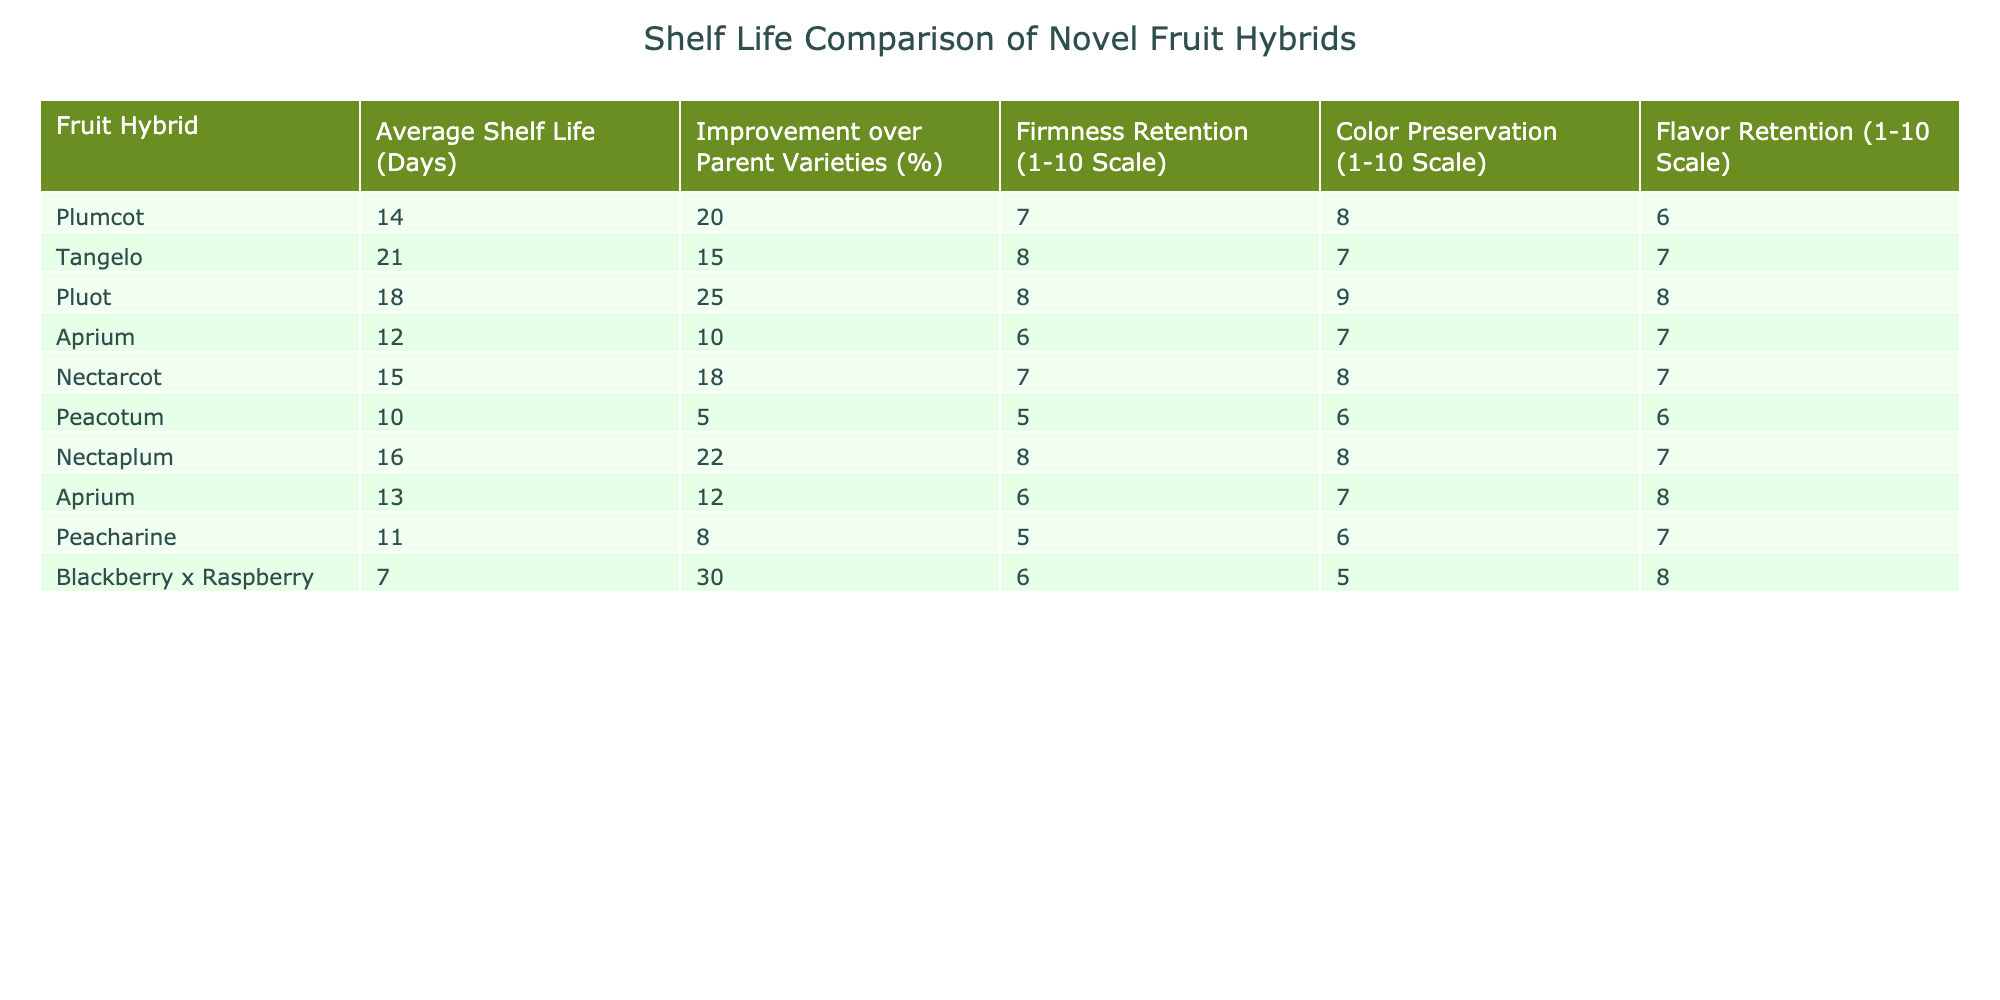What is the fruit hybrid with the longest average shelf life? By looking at the "Average Shelf Life (Days)" column, Tangelo has the highest value at 21 days compared to the other hybrids.
Answer: Tangelo Which fruit hybrid shows the greatest improvement over parent varieties? The "Improvement over Parent Varieties (%)" column shows that Blackberry x Raspberry has the highest percentage at 30%.
Answer: Blackberry x Raspberry What is the average firmness retention score for all fruit hybrids? Sum the firmness retention scores: 7 + 8 + 8 + 6 + 7 + 5 + 8 + 6 + 5 + 6 = 66. There are 10 hybrids, so the average is 66/10 = 6.6.
Answer: 6.6 How many fruit hybrids have an average shelf life greater than 15 days? The hybrids with shelf life greater than 15 days are Tangelo, Pluot, Nectaplum, and Plumcot. That makes a total of 4 hybrids.
Answer: 4 Is the flavor retention of the Plumcot higher than that of Peacotum? Comparing the "Flavor Retention (1-10 Scale)" values, Plumcot has a score of 6 while Peacotum has a score of 6. Therefore, Plumcot's flavor retention is not higher.
Answer: No Which fruit hybrids have both color and flavor retention scores of 8 or higher? Checking the "Color Preservation" and "Flavor Retention" columns, Pluot and Nectaplum both score 8 or higher in both categories.
Answer: Pluot, Nectaplum What is the difference in average shelf life between the best and worst-performing hybrid? The highest average shelf life is Tangelo at 21 days and the lowest is Peacotum at 10 days. The difference is 21 - 10 = 11 days.
Answer: 11 days How does the firmness retention of Nectarcot compare to that of Aprium? Nectarcot has a firmness retention score of 7, and Aprium has a score of 6. Nectarcot has a higher score of 1.
Answer: Yes, Nectarcot is higher by 1 Which hybrid retained the least firmness according to the table? Peacotum has the lowest firmness retention score of 5 out of 10.
Answer: Peacotum Overall, how many hybrids scored a flavor retention of 7 or higher? The hybrids that scored 7 or higher are Tangelo, Pluot, Nectarcot, Nectaplum, and Aprium, totaling 5 hybrids.
Answer: 5 